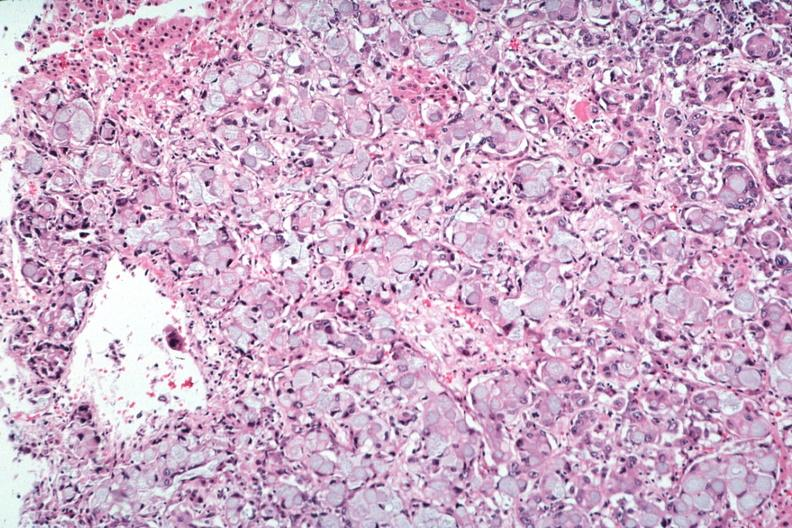does all the fat necrosis show primary in stomach?
Answer the question using a single word or phrase. No 